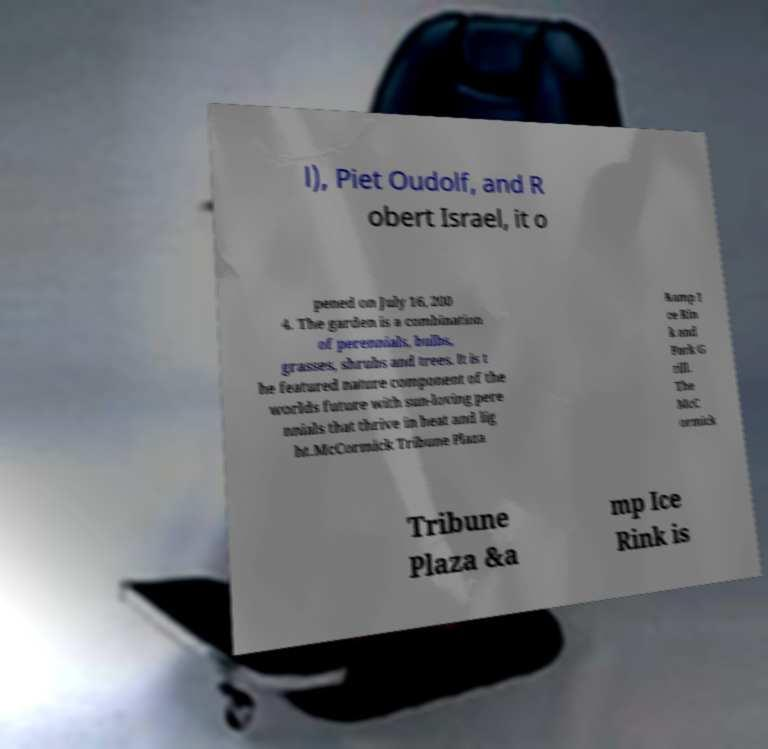I need the written content from this picture converted into text. Can you do that? l), Piet Oudolf, and R obert Israel, it o pened on July 16, 200 4. The garden is a combination of perennials, bulbs, grasses, shrubs and trees. It is t he featured nature component of the worlds future with sun-loving pere nnials that thrive in heat and lig ht.McCormick Tribune Plaza &amp I ce Rin k and Park G rill. The McC ormick Tribune Plaza &a mp Ice Rink is 